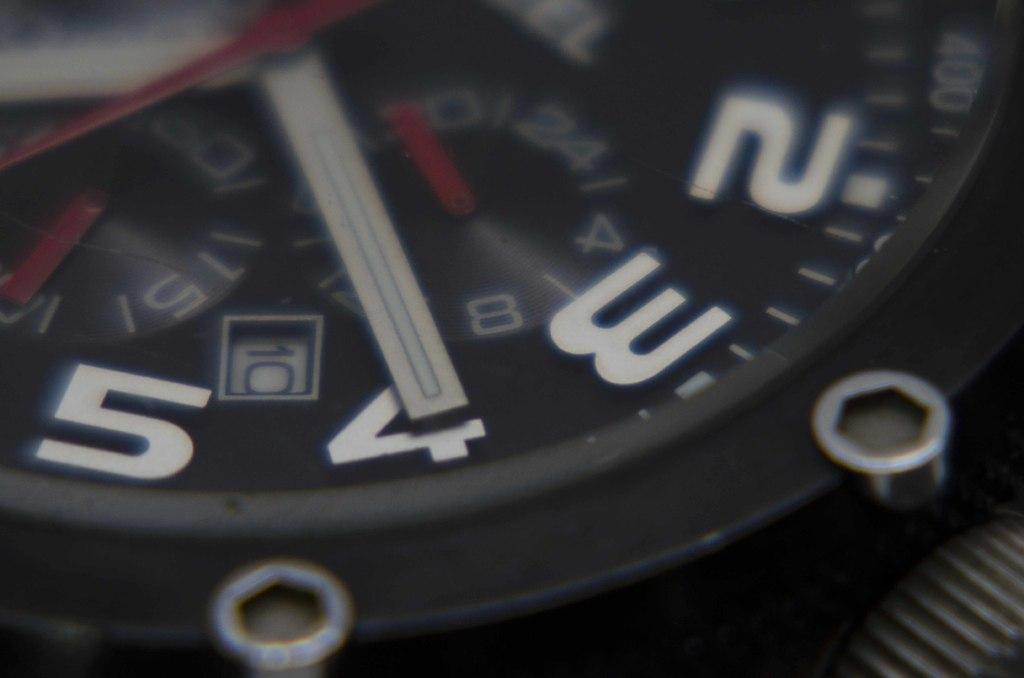<image>
Present a compact description of the photo's key features. A close up view of the numbers 2,3,4 and 5 on a watch face. 